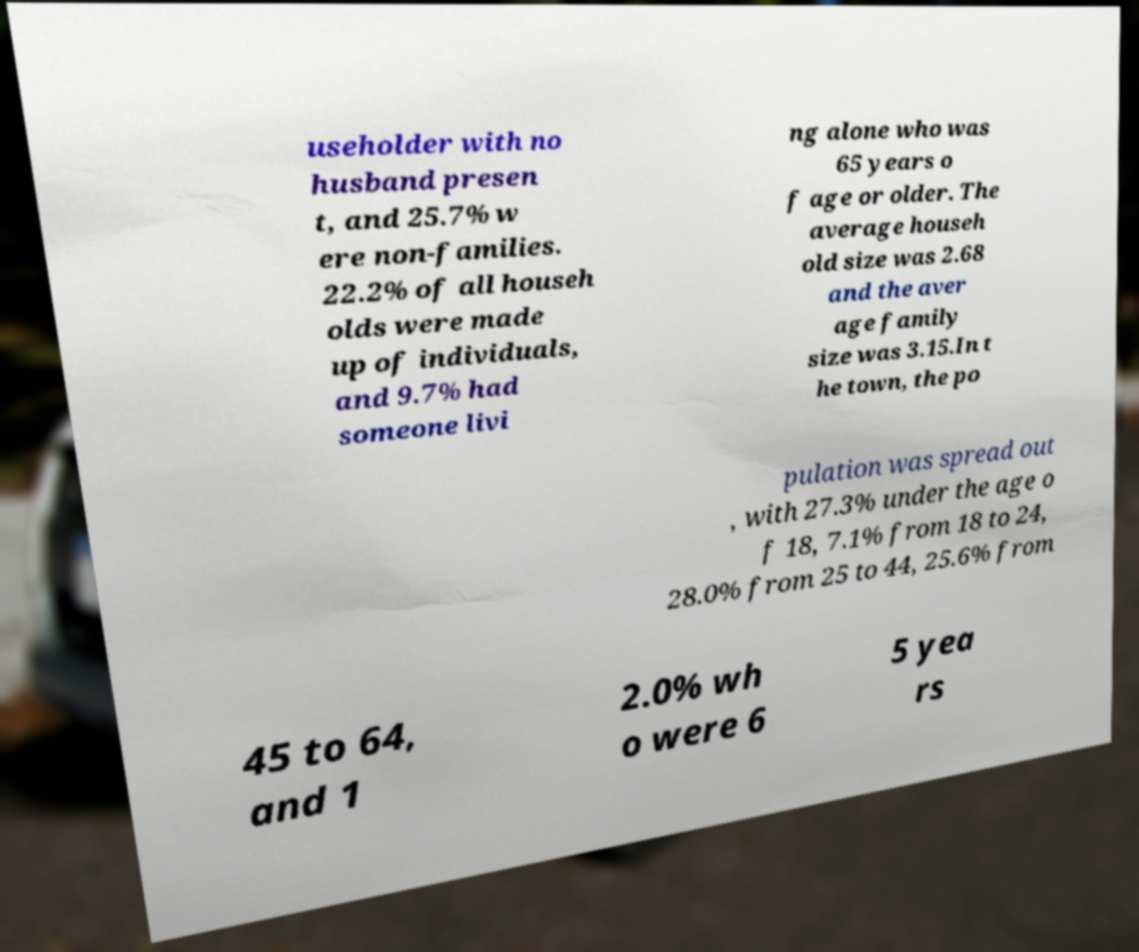There's text embedded in this image that I need extracted. Can you transcribe it verbatim? useholder with no husband presen t, and 25.7% w ere non-families. 22.2% of all househ olds were made up of individuals, and 9.7% had someone livi ng alone who was 65 years o f age or older. The average househ old size was 2.68 and the aver age family size was 3.15.In t he town, the po pulation was spread out , with 27.3% under the age o f 18, 7.1% from 18 to 24, 28.0% from 25 to 44, 25.6% from 45 to 64, and 1 2.0% wh o were 6 5 yea rs 